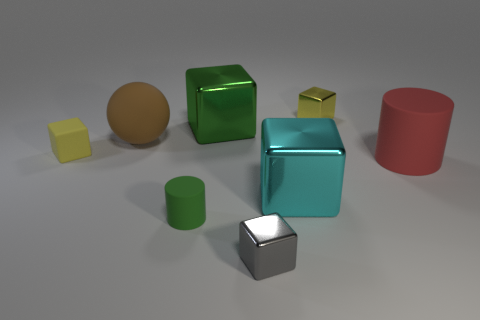Are the small yellow block that is to the right of the large brown matte object and the big green object on the left side of the big matte cylinder made of the same material?
Offer a very short reply. Yes. What is the shape of the large brown thing that is to the left of the large cylinder?
Offer a very short reply. Sphere. What size is the other thing that is the same shape as the tiny green rubber object?
Your answer should be compact. Large. Is there anything else that has the same shape as the large brown matte object?
Provide a succinct answer. No. There is a rubber cylinder in front of the big red rubber cylinder; are there any big green metallic cubes to the left of it?
Offer a very short reply. No. There is another large thing that is the same shape as the big green thing; what color is it?
Your response must be concise. Cyan. How many cubes have the same color as the small cylinder?
Your answer should be very brief. 1. What is the color of the tiny metal object that is in front of the tiny metallic object that is behind the big rubber object behind the yellow matte block?
Give a very brief answer. Gray. Is the material of the green block the same as the green cylinder?
Make the answer very short. No. Do the small green rubber object and the large red rubber object have the same shape?
Give a very brief answer. Yes. 